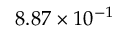<formula> <loc_0><loc_0><loc_500><loc_500>8 . 8 7 \times 1 0 ^ { - 1 }</formula> 